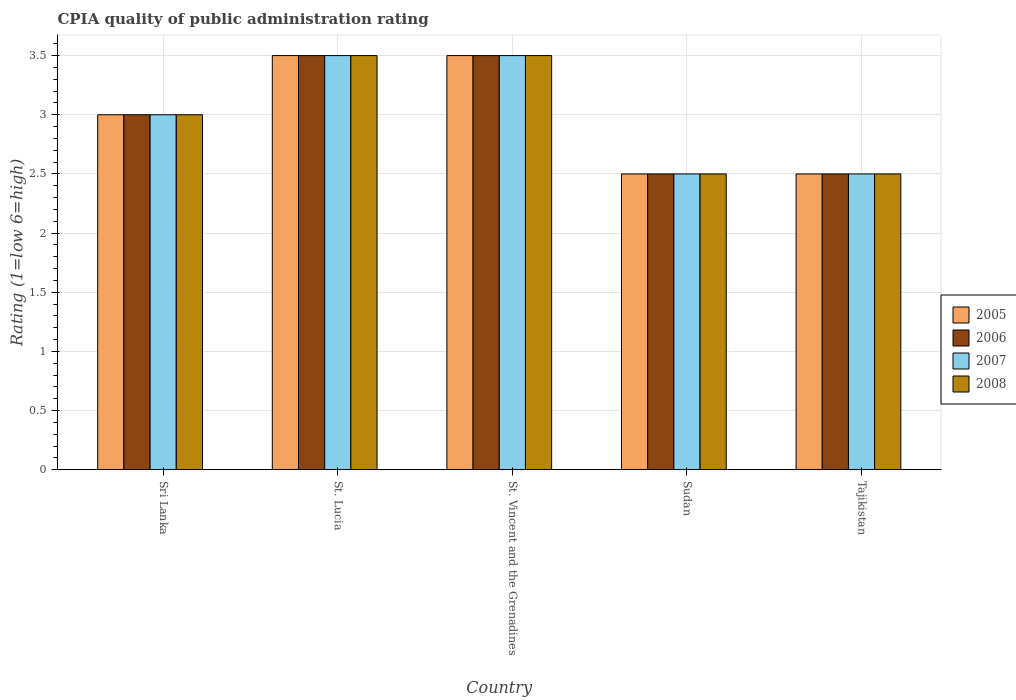How many groups of bars are there?
Your answer should be compact. 5. Are the number of bars per tick equal to the number of legend labels?
Provide a short and direct response. Yes. How many bars are there on the 4th tick from the left?
Provide a succinct answer. 4. How many bars are there on the 3rd tick from the right?
Offer a terse response. 4. What is the label of the 3rd group of bars from the left?
Offer a terse response. St. Vincent and the Grenadines. What is the CPIA rating in 2005 in Sudan?
Your answer should be compact. 2.5. Across all countries, what is the minimum CPIA rating in 2008?
Provide a short and direct response. 2.5. In which country was the CPIA rating in 2006 maximum?
Your answer should be compact. St. Lucia. In which country was the CPIA rating in 2005 minimum?
Offer a very short reply. Sudan. What is the difference between the CPIA rating of/in 2007 and CPIA rating of/in 2006 in Tajikistan?
Offer a terse response. 0. What is the ratio of the CPIA rating in 2007 in St. Vincent and the Grenadines to that in Tajikistan?
Provide a succinct answer. 1.4. What is the difference between the highest and the lowest CPIA rating in 2005?
Keep it short and to the point. 1. In how many countries, is the CPIA rating in 2008 greater than the average CPIA rating in 2008 taken over all countries?
Ensure brevity in your answer.  2. How many countries are there in the graph?
Offer a terse response. 5. What is the difference between two consecutive major ticks on the Y-axis?
Make the answer very short. 0.5. What is the title of the graph?
Offer a very short reply. CPIA quality of public administration rating. Does "1960" appear as one of the legend labels in the graph?
Give a very brief answer. No. What is the label or title of the X-axis?
Keep it short and to the point. Country. What is the Rating (1=low 6=high) in 2005 in Sri Lanka?
Keep it short and to the point. 3. What is the Rating (1=low 6=high) of 2008 in Sri Lanka?
Keep it short and to the point. 3. What is the Rating (1=low 6=high) in 2005 in St. Lucia?
Give a very brief answer. 3.5. What is the Rating (1=low 6=high) of 2008 in St. Lucia?
Make the answer very short. 3.5. What is the Rating (1=low 6=high) of 2006 in Sudan?
Make the answer very short. 2.5. What is the Rating (1=low 6=high) of 2007 in Sudan?
Keep it short and to the point. 2.5. What is the Rating (1=low 6=high) in 2008 in Sudan?
Your answer should be very brief. 2.5. What is the Rating (1=low 6=high) of 2005 in Tajikistan?
Your response must be concise. 2.5. What is the Rating (1=low 6=high) of 2006 in Tajikistan?
Ensure brevity in your answer.  2.5. What is the Rating (1=low 6=high) in 2008 in Tajikistan?
Ensure brevity in your answer.  2.5. Across all countries, what is the maximum Rating (1=low 6=high) in 2007?
Your answer should be compact. 3.5. Across all countries, what is the minimum Rating (1=low 6=high) of 2007?
Your response must be concise. 2.5. What is the total Rating (1=low 6=high) in 2006 in the graph?
Offer a very short reply. 15. What is the difference between the Rating (1=low 6=high) in 2005 in Sri Lanka and that in St. Lucia?
Make the answer very short. -0.5. What is the difference between the Rating (1=low 6=high) in 2006 in Sri Lanka and that in St. Lucia?
Provide a short and direct response. -0.5. What is the difference between the Rating (1=low 6=high) in 2006 in Sri Lanka and that in St. Vincent and the Grenadines?
Keep it short and to the point. -0.5. What is the difference between the Rating (1=low 6=high) in 2007 in Sri Lanka and that in St. Vincent and the Grenadines?
Your response must be concise. -0.5. What is the difference between the Rating (1=low 6=high) of 2008 in Sri Lanka and that in St. Vincent and the Grenadines?
Your answer should be compact. -0.5. What is the difference between the Rating (1=low 6=high) of 2006 in Sri Lanka and that in Sudan?
Your answer should be compact. 0.5. What is the difference between the Rating (1=low 6=high) in 2007 in Sri Lanka and that in Sudan?
Offer a terse response. 0.5. What is the difference between the Rating (1=low 6=high) in 2005 in Sri Lanka and that in Tajikistan?
Provide a succinct answer. 0.5. What is the difference between the Rating (1=low 6=high) in 2005 in St. Lucia and that in St. Vincent and the Grenadines?
Ensure brevity in your answer.  0. What is the difference between the Rating (1=low 6=high) in 2006 in St. Lucia and that in Sudan?
Provide a succinct answer. 1. What is the difference between the Rating (1=low 6=high) of 2007 in St. Lucia and that in Sudan?
Offer a very short reply. 1. What is the difference between the Rating (1=low 6=high) in 2006 in St. Lucia and that in Tajikistan?
Offer a very short reply. 1. What is the difference between the Rating (1=low 6=high) in 2007 in St. Lucia and that in Tajikistan?
Your answer should be very brief. 1. What is the difference between the Rating (1=low 6=high) of 2008 in St. Lucia and that in Tajikistan?
Your answer should be very brief. 1. What is the difference between the Rating (1=low 6=high) of 2005 in St. Vincent and the Grenadines and that in Sudan?
Provide a succinct answer. 1. What is the difference between the Rating (1=low 6=high) of 2006 in St. Vincent and the Grenadines and that in Sudan?
Your response must be concise. 1. What is the difference between the Rating (1=low 6=high) of 2007 in St. Vincent and the Grenadines and that in Sudan?
Give a very brief answer. 1. What is the difference between the Rating (1=low 6=high) in 2008 in St. Vincent and the Grenadines and that in Sudan?
Offer a very short reply. 1. What is the difference between the Rating (1=low 6=high) of 2007 in St. Vincent and the Grenadines and that in Tajikistan?
Give a very brief answer. 1. What is the difference between the Rating (1=low 6=high) of 2008 in St. Vincent and the Grenadines and that in Tajikistan?
Keep it short and to the point. 1. What is the difference between the Rating (1=low 6=high) of 2007 in Sudan and that in Tajikistan?
Offer a terse response. 0. What is the difference between the Rating (1=low 6=high) of 2008 in Sudan and that in Tajikistan?
Provide a succinct answer. 0. What is the difference between the Rating (1=low 6=high) of 2005 in Sri Lanka and the Rating (1=low 6=high) of 2007 in St. Lucia?
Make the answer very short. -0.5. What is the difference between the Rating (1=low 6=high) in 2005 in Sri Lanka and the Rating (1=low 6=high) in 2008 in St. Lucia?
Offer a terse response. -0.5. What is the difference between the Rating (1=low 6=high) of 2006 in Sri Lanka and the Rating (1=low 6=high) of 2007 in St. Lucia?
Make the answer very short. -0.5. What is the difference between the Rating (1=low 6=high) in 2005 in Sri Lanka and the Rating (1=low 6=high) in 2008 in St. Vincent and the Grenadines?
Provide a short and direct response. -0.5. What is the difference between the Rating (1=low 6=high) of 2006 in Sri Lanka and the Rating (1=low 6=high) of 2007 in St. Vincent and the Grenadines?
Your answer should be compact. -0.5. What is the difference between the Rating (1=low 6=high) in 2005 in Sri Lanka and the Rating (1=low 6=high) in 2007 in Sudan?
Your response must be concise. 0.5. What is the difference between the Rating (1=low 6=high) of 2005 in Sri Lanka and the Rating (1=low 6=high) of 2008 in Sudan?
Offer a terse response. 0.5. What is the difference between the Rating (1=low 6=high) of 2006 in Sri Lanka and the Rating (1=low 6=high) of 2007 in Sudan?
Give a very brief answer. 0.5. What is the difference between the Rating (1=low 6=high) in 2006 in Sri Lanka and the Rating (1=low 6=high) in 2008 in Sudan?
Make the answer very short. 0.5. What is the difference between the Rating (1=low 6=high) in 2005 in Sri Lanka and the Rating (1=low 6=high) in 2006 in Tajikistan?
Offer a very short reply. 0.5. What is the difference between the Rating (1=low 6=high) of 2005 in Sri Lanka and the Rating (1=low 6=high) of 2007 in Tajikistan?
Give a very brief answer. 0.5. What is the difference between the Rating (1=low 6=high) in 2005 in Sri Lanka and the Rating (1=low 6=high) in 2008 in Tajikistan?
Your answer should be very brief. 0.5. What is the difference between the Rating (1=low 6=high) of 2006 in Sri Lanka and the Rating (1=low 6=high) of 2008 in Tajikistan?
Provide a succinct answer. 0.5. What is the difference between the Rating (1=low 6=high) in 2007 in Sri Lanka and the Rating (1=low 6=high) in 2008 in Tajikistan?
Your response must be concise. 0.5. What is the difference between the Rating (1=low 6=high) of 2005 in St. Lucia and the Rating (1=low 6=high) of 2006 in St. Vincent and the Grenadines?
Offer a terse response. 0. What is the difference between the Rating (1=low 6=high) of 2005 in St. Lucia and the Rating (1=low 6=high) of 2007 in St. Vincent and the Grenadines?
Your answer should be very brief. 0. What is the difference between the Rating (1=low 6=high) of 2005 in St. Lucia and the Rating (1=low 6=high) of 2008 in St. Vincent and the Grenadines?
Provide a short and direct response. 0. What is the difference between the Rating (1=low 6=high) of 2006 in St. Lucia and the Rating (1=low 6=high) of 2008 in St. Vincent and the Grenadines?
Make the answer very short. 0. What is the difference between the Rating (1=low 6=high) of 2005 in St. Lucia and the Rating (1=low 6=high) of 2008 in Sudan?
Give a very brief answer. 1. What is the difference between the Rating (1=low 6=high) of 2006 in St. Lucia and the Rating (1=low 6=high) of 2007 in Sudan?
Your response must be concise. 1. What is the difference between the Rating (1=low 6=high) in 2005 in St. Lucia and the Rating (1=low 6=high) in 2006 in Tajikistan?
Your answer should be very brief. 1. What is the difference between the Rating (1=low 6=high) in 2006 in St. Lucia and the Rating (1=low 6=high) in 2008 in Tajikistan?
Give a very brief answer. 1. What is the difference between the Rating (1=low 6=high) in 2005 in St. Vincent and the Grenadines and the Rating (1=low 6=high) in 2007 in Sudan?
Make the answer very short. 1. What is the difference between the Rating (1=low 6=high) in 2006 in St. Vincent and the Grenadines and the Rating (1=low 6=high) in 2008 in Sudan?
Provide a succinct answer. 1. What is the difference between the Rating (1=low 6=high) of 2007 in St. Vincent and the Grenadines and the Rating (1=low 6=high) of 2008 in Sudan?
Offer a terse response. 1. What is the difference between the Rating (1=low 6=high) of 2005 in St. Vincent and the Grenadines and the Rating (1=low 6=high) of 2006 in Tajikistan?
Offer a very short reply. 1. What is the difference between the Rating (1=low 6=high) in 2005 in St. Vincent and the Grenadines and the Rating (1=low 6=high) in 2007 in Tajikistan?
Ensure brevity in your answer.  1. What is the difference between the Rating (1=low 6=high) in 2006 in St. Vincent and the Grenadines and the Rating (1=low 6=high) in 2007 in Tajikistan?
Keep it short and to the point. 1. What is the difference between the Rating (1=low 6=high) of 2006 in St. Vincent and the Grenadines and the Rating (1=low 6=high) of 2008 in Tajikistan?
Your answer should be compact. 1. What is the difference between the Rating (1=low 6=high) in 2005 in Sudan and the Rating (1=low 6=high) in 2007 in Tajikistan?
Your answer should be very brief. 0. What is the difference between the Rating (1=low 6=high) of 2006 in Sudan and the Rating (1=low 6=high) of 2007 in Tajikistan?
Provide a succinct answer. 0. What is the difference between the Rating (1=low 6=high) in 2006 in Sudan and the Rating (1=low 6=high) in 2008 in Tajikistan?
Offer a terse response. 0. What is the average Rating (1=low 6=high) in 2006 per country?
Provide a short and direct response. 3. What is the average Rating (1=low 6=high) of 2007 per country?
Provide a succinct answer. 3. What is the average Rating (1=low 6=high) in 2008 per country?
Keep it short and to the point. 3. What is the difference between the Rating (1=low 6=high) of 2005 and Rating (1=low 6=high) of 2006 in Sri Lanka?
Your answer should be very brief. 0. What is the difference between the Rating (1=low 6=high) in 2006 and Rating (1=low 6=high) in 2007 in Sri Lanka?
Make the answer very short. 0. What is the difference between the Rating (1=low 6=high) of 2005 and Rating (1=low 6=high) of 2006 in St. Lucia?
Keep it short and to the point. 0. What is the difference between the Rating (1=low 6=high) of 2005 and Rating (1=low 6=high) of 2007 in St. Lucia?
Offer a very short reply. 0. What is the difference between the Rating (1=low 6=high) of 2005 and Rating (1=low 6=high) of 2008 in St. Lucia?
Keep it short and to the point. 0. What is the difference between the Rating (1=low 6=high) of 2006 and Rating (1=low 6=high) of 2007 in St. Lucia?
Keep it short and to the point. 0. What is the difference between the Rating (1=low 6=high) of 2006 and Rating (1=low 6=high) of 2008 in St. Lucia?
Offer a very short reply. 0. What is the difference between the Rating (1=low 6=high) in 2007 and Rating (1=low 6=high) in 2008 in St. Lucia?
Your response must be concise. 0. What is the difference between the Rating (1=low 6=high) in 2005 and Rating (1=low 6=high) in 2006 in St. Vincent and the Grenadines?
Provide a succinct answer. 0. What is the difference between the Rating (1=low 6=high) of 2005 and Rating (1=low 6=high) of 2008 in St. Vincent and the Grenadines?
Make the answer very short. 0. What is the difference between the Rating (1=low 6=high) in 2006 and Rating (1=low 6=high) in 2008 in St. Vincent and the Grenadines?
Your answer should be compact. 0. What is the difference between the Rating (1=low 6=high) in 2007 and Rating (1=low 6=high) in 2008 in St. Vincent and the Grenadines?
Your answer should be very brief. 0. What is the difference between the Rating (1=low 6=high) of 2005 and Rating (1=low 6=high) of 2008 in Sudan?
Your answer should be compact. 0. What is the difference between the Rating (1=low 6=high) in 2006 and Rating (1=low 6=high) in 2008 in Sudan?
Give a very brief answer. 0. What is the difference between the Rating (1=low 6=high) in 2007 and Rating (1=low 6=high) in 2008 in Sudan?
Provide a short and direct response. 0. What is the difference between the Rating (1=low 6=high) in 2005 and Rating (1=low 6=high) in 2006 in Tajikistan?
Give a very brief answer. 0. What is the difference between the Rating (1=low 6=high) of 2005 and Rating (1=low 6=high) of 2007 in Tajikistan?
Offer a very short reply. 0. What is the difference between the Rating (1=low 6=high) of 2005 and Rating (1=low 6=high) of 2008 in Tajikistan?
Keep it short and to the point. 0. What is the difference between the Rating (1=low 6=high) of 2006 and Rating (1=low 6=high) of 2007 in Tajikistan?
Provide a succinct answer. 0. What is the ratio of the Rating (1=low 6=high) of 2005 in Sri Lanka to that in St. Lucia?
Offer a very short reply. 0.86. What is the ratio of the Rating (1=low 6=high) of 2007 in Sri Lanka to that in St. Lucia?
Offer a very short reply. 0.86. What is the ratio of the Rating (1=low 6=high) in 2008 in Sri Lanka to that in St. Lucia?
Provide a succinct answer. 0.86. What is the ratio of the Rating (1=low 6=high) in 2006 in Sri Lanka to that in St. Vincent and the Grenadines?
Provide a short and direct response. 0.86. What is the ratio of the Rating (1=low 6=high) of 2006 in Sri Lanka to that in Sudan?
Offer a terse response. 1.2. What is the ratio of the Rating (1=low 6=high) in 2007 in Sri Lanka to that in Sudan?
Your answer should be compact. 1.2. What is the ratio of the Rating (1=low 6=high) of 2006 in Sri Lanka to that in Tajikistan?
Make the answer very short. 1.2. What is the ratio of the Rating (1=low 6=high) in 2005 in St. Lucia to that in St. Vincent and the Grenadines?
Give a very brief answer. 1. What is the ratio of the Rating (1=low 6=high) in 2006 in St. Lucia to that in St. Vincent and the Grenadines?
Your response must be concise. 1. What is the ratio of the Rating (1=low 6=high) of 2007 in St. Lucia to that in St. Vincent and the Grenadines?
Make the answer very short. 1. What is the ratio of the Rating (1=low 6=high) in 2005 in St. Lucia to that in Sudan?
Make the answer very short. 1.4. What is the ratio of the Rating (1=low 6=high) in 2007 in St. Lucia to that in Sudan?
Your response must be concise. 1.4. What is the ratio of the Rating (1=low 6=high) of 2008 in St. Lucia to that in Sudan?
Keep it short and to the point. 1.4. What is the ratio of the Rating (1=low 6=high) of 2005 in St. Lucia to that in Tajikistan?
Your response must be concise. 1.4. What is the ratio of the Rating (1=low 6=high) of 2007 in St. Lucia to that in Tajikistan?
Provide a succinct answer. 1.4. What is the ratio of the Rating (1=low 6=high) in 2008 in St. Vincent and the Grenadines to that in Sudan?
Give a very brief answer. 1.4. What is the ratio of the Rating (1=low 6=high) of 2006 in St. Vincent and the Grenadines to that in Tajikistan?
Your response must be concise. 1.4. What is the ratio of the Rating (1=low 6=high) in 2007 in St. Vincent and the Grenadines to that in Tajikistan?
Provide a short and direct response. 1.4. What is the ratio of the Rating (1=low 6=high) in 2005 in Sudan to that in Tajikistan?
Ensure brevity in your answer.  1. What is the difference between the highest and the second highest Rating (1=low 6=high) of 2008?
Provide a succinct answer. 0. 